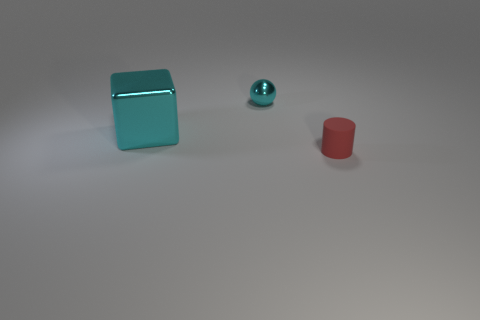Add 2 tiny green rubber cubes. How many objects exist? 5 Subtract all gray cubes. How many red balls are left? 0 Subtract all small red cylinders. Subtract all small matte cylinders. How many objects are left? 1 Add 1 large cyan shiny cubes. How many large cyan shiny cubes are left? 2 Add 2 big cyan rubber spheres. How many big cyan rubber spheres exist? 2 Subtract 0 gray spheres. How many objects are left? 3 Subtract all cubes. How many objects are left? 2 Subtract 1 balls. How many balls are left? 0 Subtract all cyan cylinders. Subtract all red spheres. How many cylinders are left? 1 